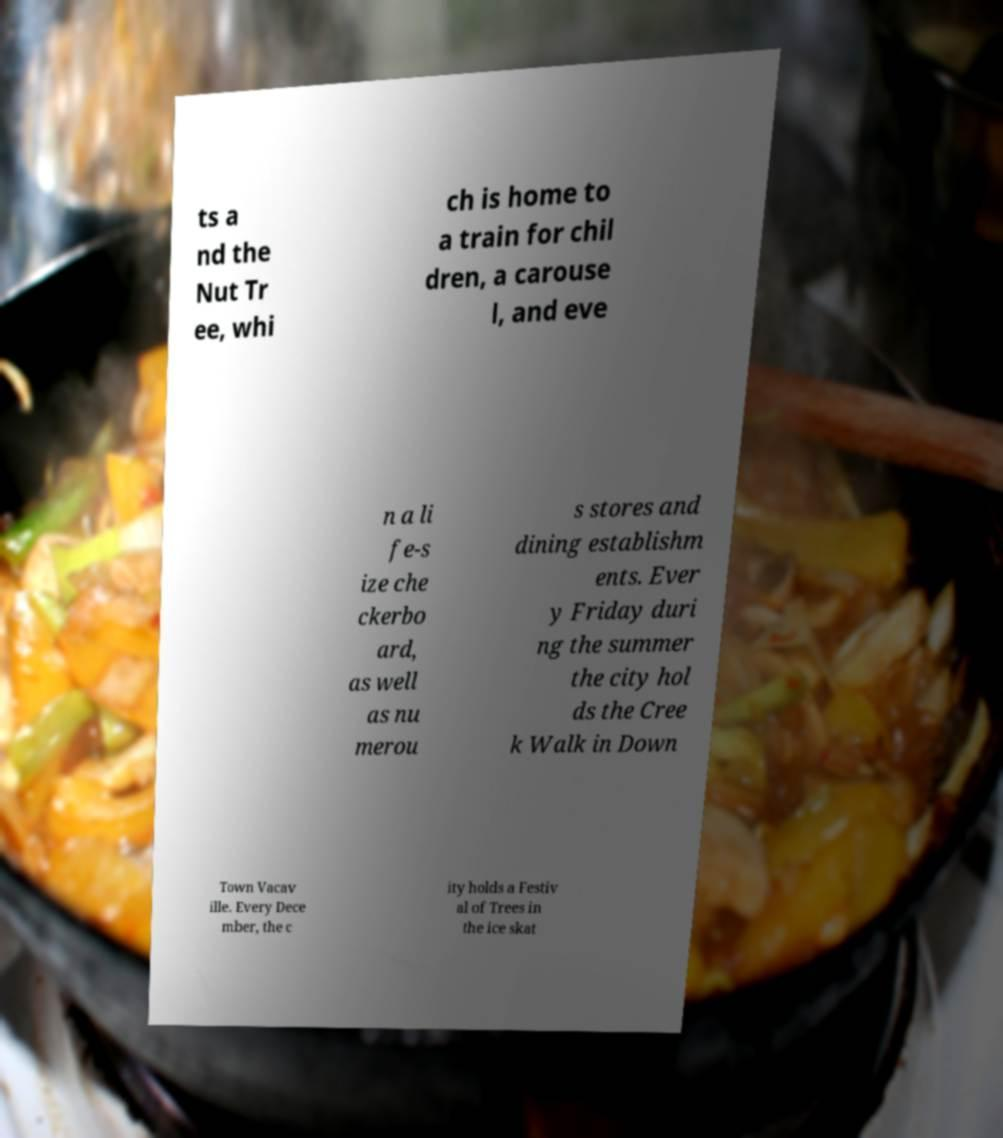What messages or text are displayed in this image? I need them in a readable, typed format. ts a nd the Nut Tr ee, whi ch is home to a train for chil dren, a carouse l, and eve n a li fe-s ize che ckerbo ard, as well as nu merou s stores and dining establishm ents. Ever y Friday duri ng the summer the city hol ds the Cree k Walk in Down Town Vacav ille. Every Dece mber, the c ity holds a Festiv al of Trees in the ice skat 